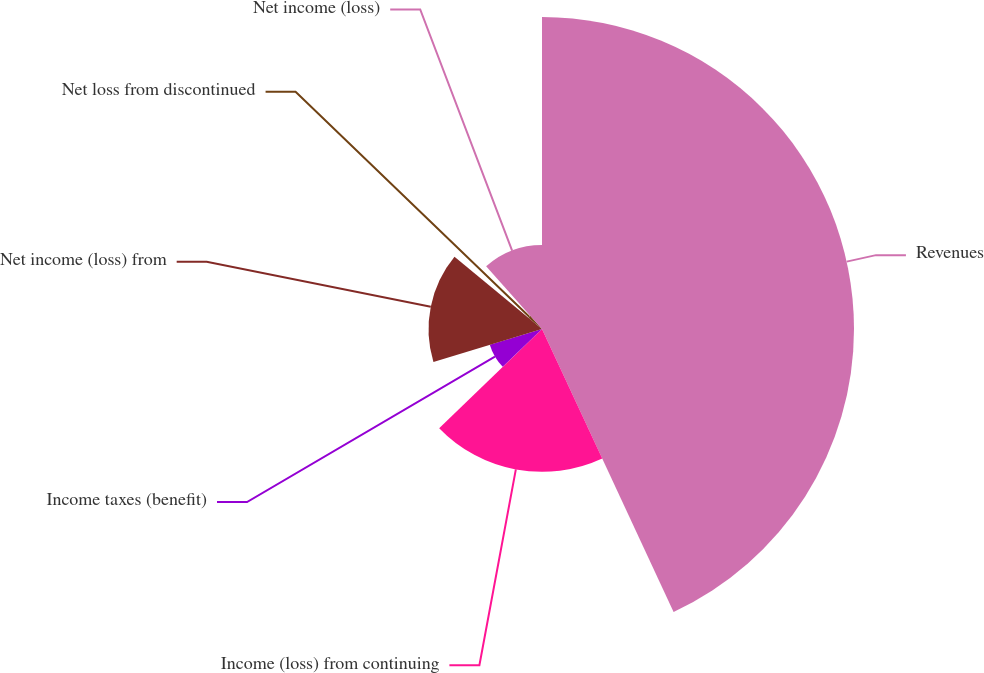Convert chart. <chart><loc_0><loc_0><loc_500><loc_500><pie_chart><fcel>Revenues<fcel>Income (loss) from continuing<fcel>Income taxes (benefit)<fcel>Net income (loss) from<fcel>Net loss from discontinued<fcel>Net income (loss)<nl><fcel>43.07%<fcel>19.72%<fcel>7.53%<fcel>15.66%<fcel>2.43%<fcel>11.59%<nl></chart> 